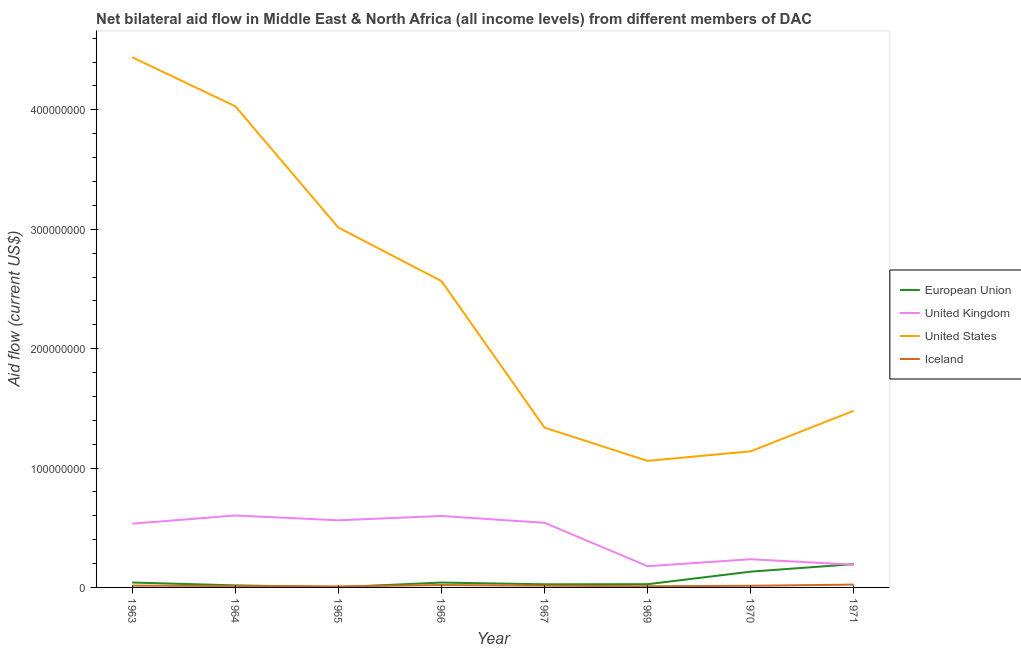How many different coloured lines are there?
Ensure brevity in your answer.  4. Is the number of lines equal to the number of legend labels?
Your answer should be very brief. Yes. What is the amount of aid given by eu in 1970?
Keep it short and to the point. 1.32e+07. Across all years, what is the maximum amount of aid given by uk?
Provide a short and direct response. 6.02e+07. Across all years, what is the minimum amount of aid given by us?
Provide a short and direct response. 1.06e+08. In which year was the amount of aid given by eu minimum?
Your answer should be very brief. 1965. What is the total amount of aid given by eu in the graph?
Provide a succinct answer. 4.82e+07. What is the difference between the amount of aid given by eu in 1963 and that in 1964?
Offer a very short reply. 2.40e+06. What is the difference between the amount of aid given by eu in 1969 and the amount of aid given by iceland in 1971?
Provide a short and direct response. 3.50e+05. What is the average amount of aid given by iceland per year?
Offer a very short reply. 1.46e+06. In the year 1967, what is the difference between the amount of aid given by eu and amount of aid given by us?
Your response must be concise. -1.31e+08. In how many years, is the amount of aid given by us greater than 300000000 US$?
Provide a succinct answer. 3. What is the ratio of the amount of aid given by us in 1966 to that in 1969?
Offer a very short reply. 2.42. Is the amount of aid given by uk in 1963 less than that in 1969?
Provide a succinct answer. No. What is the difference between the highest and the second highest amount of aid given by iceland?
Make the answer very short. 3.50e+05. What is the difference between the highest and the lowest amount of aid given by eu?
Give a very brief answer. 1.93e+07. In how many years, is the amount of aid given by uk greater than the average amount of aid given by uk taken over all years?
Make the answer very short. 5. Is it the case that in every year, the sum of the amount of aid given by eu and amount of aid given by uk is greater than the amount of aid given by us?
Provide a short and direct response. No. Does the amount of aid given by iceland monotonically increase over the years?
Your response must be concise. No. How many lines are there?
Your answer should be very brief. 4. What is the difference between two consecutive major ticks on the Y-axis?
Provide a succinct answer. 1.00e+08. Does the graph contain any zero values?
Ensure brevity in your answer.  No. Does the graph contain grids?
Give a very brief answer. No. Where does the legend appear in the graph?
Offer a very short reply. Center right. What is the title of the graph?
Ensure brevity in your answer.  Net bilateral aid flow in Middle East & North Africa (all income levels) from different members of DAC. What is the Aid flow (current US$) in European Union in 1963?
Give a very brief answer. 4.11e+06. What is the Aid flow (current US$) of United Kingdom in 1963?
Keep it short and to the point. 5.34e+07. What is the Aid flow (current US$) of United States in 1963?
Keep it short and to the point. 4.44e+08. What is the Aid flow (current US$) of Iceland in 1963?
Provide a short and direct response. 1.54e+06. What is the Aid flow (current US$) of European Union in 1964?
Your response must be concise. 1.71e+06. What is the Aid flow (current US$) in United Kingdom in 1964?
Your answer should be compact. 6.02e+07. What is the Aid flow (current US$) in United States in 1964?
Offer a terse response. 4.03e+08. What is the Aid flow (current US$) in Iceland in 1964?
Your response must be concise. 1.10e+06. What is the Aid flow (current US$) in United Kingdom in 1965?
Your answer should be very brief. 5.62e+07. What is the Aid flow (current US$) of United States in 1965?
Your answer should be very brief. 3.01e+08. What is the Aid flow (current US$) in Iceland in 1965?
Offer a very short reply. 8.70e+05. What is the Aid flow (current US$) of European Union in 1966?
Your answer should be very brief. 4.08e+06. What is the Aid flow (current US$) in United Kingdom in 1966?
Offer a very short reply. 5.98e+07. What is the Aid flow (current US$) of United States in 1966?
Provide a succinct answer. 2.57e+08. What is the Aid flow (current US$) in Iceland in 1966?
Provide a succinct answer. 2.01e+06. What is the Aid flow (current US$) in European Union in 1967?
Ensure brevity in your answer.  2.62e+06. What is the Aid flow (current US$) in United Kingdom in 1967?
Provide a succinct answer. 5.41e+07. What is the Aid flow (current US$) in United States in 1967?
Your answer should be very brief. 1.34e+08. What is the Aid flow (current US$) of Iceland in 1967?
Ensure brevity in your answer.  1.44e+06. What is the Aid flow (current US$) in European Union in 1969?
Your answer should be very brief. 2.71e+06. What is the Aid flow (current US$) of United Kingdom in 1969?
Ensure brevity in your answer.  1.78e+07. What is the Aid flow (current US$) of United States in 1969?
Ensure brevity in your answer.  1.06e+08. What is the Aid flow (current US$) in Iceland in 1969?
Your answer should be compact. 9.70e+05. What is the Aid flow (current US$) of European Union in 1970?
Provide a short and direct response. 1.32e+07. What is the Aid flow (current US$) of United Kingdom in 1970?
Keep it short and to the point. 2.36e+07. What is the Aid flow (current US$) in United States in 1970?
Ensure brevity in your answer.  1.14e+08. What is the Aid flow (current US$) of Iceland in 1970?
Provide a short and direct response. 1.37e+06. What is the Aid flow (current US$) of European Union in 1971?
Provide a short and direct response. 1.95e+07. What is the Aid flow (current US$) of United Kingdom in 1971?
Your response must be concise. 1.90e+07. What is the Aid flow (current US$) in United States in 1971?
Your answer should be compact. 1.48e+08. What is the Aid flow (current US$) of Iceland in 1971?
Keep it short and to the point. 2.36e+06. Across all years, what is the maximum Aid flow (current US$) of European Union?
Your answer should be compact. 1.95e+07. Across all years, what is the maximum Aid flow (current US$) in United Kingdom?
Offer a very short reply. 6.02e+07. Across all years, what is the maximum Aid flow (current US$) of United States?
Your response must be concise. 4.44e+08. Across all years, what is the maximum Aid flow (current US$) in Iceland?
Provide a succinct answer. 2.36e+06. Across all years, what is the minimum Aid flow (current US$) of European Union?
Offer a very short reply. 2.20e+05. Across all years, what is the minimum Aid flow (current US$) of United Kingdom?
Your answer should be very brief. 1.78e+07. Across all years, what is the minimum Aid flow (current US$) in United States?
Give a very brief answer. 1.06e+08. Across all years, what is the minimum Aid flow (current US$) of Iceland?
Offer a very short reply. 8.70e+05. What is the total Aid flow (current US$) of European Union in the graph?
Provide a succinct answer. 4.82e+07. What is the total Aid flow (current US$) in United Kingdom in the graph?
Offer a terse response. 3.44e+08. What is the total Aid flow (current US$) of United States in the graph?
Provide a short and direct response. 1.91e+09. What is the total Aid flow (current US$) of Iceland in the graph?
Offer a very short reply. 1.17e+07. What is the difference between the Aid flow (current US$) in European Union in 1963 and that in 1964?
Ensure brevity in your answer.  2.40e+06. What is the difference between the Aid flow (current US$) of United Kingdom in 1963 and that in 1964?
Your answer should be compact. -6.86e+06. What is the difference between the Aid flow (current US$) of United States in 1963 and that in 1964?
Provide a short and direct response. 4.10e+07. What is the difference between the Aid flow (current US$) of European Union in 1963 and that in 1965?
Make the answer very short. 3.89e+06. What is the difference between the Aid flow (current US$) of United Kingdom in 1963 and that in 1965?
Provide a succinct answer. -2.85e+06. What is the difference between the Aid flow (current US$) in United States in 1963 and that in 1965?
Your response must be concise. 1.43e+08. What is the difference between the Aid flow (current US$) of Iceland in 1963 and that in 1965?
Your response must be concise. 6.70e+05. What is the difference between the Aid flow (current US$) in European Union in 1963 and that in 1966?
Provide a succinct answer. 3.00e+04. What is the difference between the Aid flow (current US$) in United Kingdom in 1963 and that in 1966?
Give a very brief answer. -6.46e+06. What is the difference between the Aid flow (current US$) of United States in 1963 and that in 1966?
Your response must be concise. 1.87e+08. What is the difference between the Aid flow (current US$) in Iceland in 1963 and that in 1966?
Provide a succinct answer. -4.70e+05. What is the difference between the Aid flow (current US$) in European Union in 1963 and that in 1967?
Give a very brief answer. 1.49e+06. What is the difference between the Aid flow (current US$) of United Kingdom in 1963 and that in 1967?
Keep it short and to the point. -7.60e+05. What is the difference between the Aid flow (current US$) in United States in 1963 and that in 1967?
Give a very brief answer. 3.10e+08. What is the difference between the Aid flow (current US$) of European Union in 1963 and that in 1969?
Give a very brief answer. 1.40e+06. What is the difference between the Aid flow (current US$) in United Kingdom in 1963 and that in 1969?
Your response must be concise. 3.56e+07. What is the difference between the Aid flow (current US$) in United States in 1963 and that in 1969?
Offer a very short reply. 3.38e+08. What is the difference between the Aid flow (current US$) in Iceland in 1963 and that in 1969?
Offer a very short reply. 5.70e+05. What is the difference between the Aid flow (current US$) in European Union in 1963 and that in 1970?
Keep it short and to the point. -9.11e+06. What is the difference between the Aid flow (current US$) in United Kingdom in 1963 and that in 1970?
Provide a succinct answer. 2.98e+07. What is the difference between the Aid flow (current US$) of United States in 1963 and that in 1970?
Offer a terse response. 3.30e+08. What is the difference between the Aid flow (current US$) of European Union in 1963 and that in 1971?
Give a very brief answer. -1.54e+07. What is the difference between the Aid flow (current US$) of United Kingdom in 1963 and that in 1971?
Your answer should be compact. 3.43e+07. What is the difference between the Aid flow (current US$) in United States in 1963 and that in 1971?
Offer a very short reply. 2.96e+08. What is the difference between the Aid flow (current US$) in Iceland in 1963 and that in 1971?
Your answer should be compact. -8.20e+05. What is the difference between the Aid flow (current US$) of European Union in 1964 and that in 1965?
Your answer should be compact. 1.49e+06. What is the difference between the Aid flow (current US$) in United Kingdom in 1964 and that in 1965?
Offer a terse response. 4.01e+06. What is the difference between the Aid flow (current US$) of United States in 1964 and that in 1965?
Your response must be concise. 1.02e+08. What is the difference between the Aid flow (current US$) of Iceland in 1964 and that in 1965?
Give a very brief answer. 2.30e+05. What is the difference between the Aid flow (current US$) of European Union in 1964 and that in 1966?
Your answer should be compact. -2.37e+06. What is the difference between the Aid flow (current US$) in United Kingdom in 1964 and that in 1966?
Your answer should be compact. 4.00e+05. What is the difference between the Aid flow (current US$) of United States in 1964 and that in 1966?
Ensure brevity in your answer.  1.46e+08. What is the difference between the Aid flow (current US$) of Iceland in 1964 and that in 1966?
Your answer should be very brief. -9.10e+05. What is the difference between the Aid flow (current US$) in European Union in 1964 and that in 1967?
Provide a short and direct response. -9.10e+05. What is the difference between the Aid flow (current US$) in United Kingdom in 1964 and that in 1967?
Make the answer very short. 6.10e+06. What is the difference between the Aid flow (current US$) in United States in 1964 and that in 1967?
Make the answer very short. 2.69e+08. What is the difference between the Aid flow (current US$) in Iceland in 1964 and that in 1967?
Give a very brief answer. -3.40e+05. What is the difference between the Aid flow (current US$) in European Union in 1964 and that in 1969?
Provide a short and direct response. -1.00e+06. What is the difference between the Aid flow (current US$) in United Kingdom in 1964 and that in 1969?
Make the answer very short. 4.25e+07. What is the difference between the Aid flow (current US$) of United States in 1964 and that in 1969?
Your response must be concise. 2.97e+08. What is the difference between the Aid flow (current US$) of Iceland in 1964 and that in 1969?
Make the answer very short. 1.30e+05. What is the difference between the Aid flow (current US$) of European Union in 1964 and that in 1970?
Your answer should be compact. -1.15e+07. What is the difference between the Aid flow (current US$) of United Kingdom in 1964 and that in 1970?
Provide a succinct answer. 3.66e+07. What is the difference between the Aid flow (current US$) of United States in 1964 and that in 1970?
Provide a short and direct response. 2.89e+08. What is the difference between the Aid flow (current US$) of Iceland in 1964 and that in 1970?
Your answer should be compact. -2.70e+05. What is the difference between the Aid flow (current US$) of European Union in 1964 and that in 1971?
Ensure brevity in your answer.  -1.78e+07. What is the difference between the Aid flow (current US$) in United Kingdom in 1964 and that in 1971?
Your answer should be compact. 4.12e+07. What is the difference between the Aid flow (current US$) of United States in 1964 and that in 1971?
Keep it short and to the point. 2.55e+08. What is the difference between the Aid flow (current US$) of Iceland in 1964 and that in 1971?
Give a very brief answer. -1.26e+06. What is the difference between the Aid flow (current US$) of European Union in 1965 and that in 1966?
Your answer should be very brief. -3.86e+06. What is the difference between the Aid flow (current US$) of United Kingdom in 1965 and that in 1966?
Your answer should be compact. -3.61e+06. What is the difference between the Aid flow (current US$) in United States in 1965 and that in 1966?
Ensure brevity in your answer.  4.48e+07. What is the difference between the Aid flow (current US$) of Iceland in 1965 and that in 1966?
Ensure brevity in your answer.  -1.14e+06. What is the difference between the Aid flow (current US$) in European Union in 1965 and that in 1967?
Your answer should be compact. -2.40e+06. What is the difference between the Aid flow (current US$) in United Kingdom in 1965 and that in 1967?
Your response must be concise. 2.09e+06. What is the difference between the Aid flow (current US$) of United States in 1965 and that in 1967?
Your answer should be compact. 1.68e+08. What is the difference between the Aid flow (current US$) in Iceland in 1965 and that in 1967?
Give a very brief answer. -5.70e+05. What is the difference between the Aid flow (current US$) in European Union in 1965 and that in 1969?
Ensure brevity in your answer.  -2.49e+06. What is the difference between the Aid flow (current US$) of United Kingdom in 1965 and that in 1969?
Keep it short and to the point. 3.84e+07. What is the difference between the Aid flow (current US$) in United States in 1965 and that in 1969?
Offer a terse response. 1.95e+08. What is the difference between the Aid flow (current US$) in European Union in 1965 and that in 1970?
Provide a short and direct response. -1.30e+07. What is the difference between the Aid flow (current US$) in United Kingdom in 1965 and that in 1970?
Keep it short and to the point. 3.26e+07. What is the difference between the Aid flow (current US$) of United States in 1965 and that in 1970?
Your response must be concise. 1.87e+08. What is the difference between the Aid flow (current US$) in Iceland in 1965 and that in 1970?
Make the answer very short. -5.00e+05. What is the difference between the Aid flow (current US$) in European Union in 1965 and that in 1971?
Provide a short and direct response. -1.93e+07. What is the difference between the Aid flow (current US$) in United Kingdom in 1965 and that in 1971?
Offer a very short reply. 3.72e+07. What is the difference between the Aid flow (current US$) of United States in 1965 and that in 1971?
Provide a short and direct response. 1.53e+08. What is the difference between the Aid flow (current US$) in Iceland in 1965 and that in 1971?
Your answer should be compact. -1.49e+06. What is the difference between the Aid flow (current US$) of European Union in 1966 and that in 1967?
Give a very brief answer. 1.46e+06. What is the difference between the Aid flow (current US$) of United Kingdom in 1966 and that in 1967?
Your answer should be compact. 5.70e+06. What is the difference between the Aid flow (current US$) in United States in 1966 and that in 1967?
Offer a very short reply. 1.23e+08. What is the difference between the Aid flow (current US$) of Iceland in 1966 and that in 1967?
Make the answer very short. 5.70e+05. What is the difference between the Aid flow (current US$) of European Union in 1966 and that in 1969?
Give a very brief answer. 1.37e+06. What is the difference between the Aid flow (current US$) of United Kingdom in 1966 and that in 1969?
Provide a succinct answer. 4.21e+07. What is the difference between the Aid flow (current US$) of United States in 1966 and that in 1969?
Keep it short and to the point. 1.51e+08. What is the difference between the Aid flow (current US$) of Iceland in 1966 and that in 1969?
Your answer should be very brief. 1.04e+06. What is the difference between the Aid flow (current US$) in European Union in 1966 and that in 1970?
Offer a very short reply. -9.14e+06. What is the difference between the Aid flow (current US$) of United Kingdom in 1966 and that in 1970?
Your answer should be very brief. 3.62e+07. What is the difference between the Aid flow (current US$) of United States in 1966 and that in 1970?
Give a very brief answer. 1.43e+08. What is the difference between the Aid flow (current US$) in Iceland in 1966 and that in 1970?
Make the answer very short. 6.40e+05. What is the difference between the Aid flow (current US$) of European Union in 1966 and that in 1971?
Offer a very short reply. -1.54e+07. What is the difference between the Aid flow (current US$) in United Kingdom in 1966 and that in 1971?
Give a very brief answer. 4.08e+07. What is the difference between the Aid flow (current US$) of United States in 1966 and that in 1971?
Your answer should be compact. 1.09e+08. What is the difference between the Aid flow (current US$) of Iceland in 1966 and that in 1971?
Provide a succinct answer. -3.50e+05. What is the difference between the Aid flow (current US$) of United Kingdom in 1967 and that in 1969?
Provide a short and direct response. 3.64e+07. What is the difference between the Aid flow (current US$) of United States in 1967 and that in 1969?
Give a very brief answer. 2.78e+07. What is the difference between the Aid flow (current US$) in Iceland in 1967 and that in 1969?
Give a very brief answer. 4.70e+05. What is the difference between the Aid flow (current US$) in European Union in 1967 and that in 1970?
Offer a terse response. -1.06e+07. What is the difference between the Aid flow (current US$) in United Kingdom in 1967 and that in 1970?
Offer a very short reply. 3.05e+07. What is the difference between the Aid flow (current US$) of United States in 1967 and that in 1970?
Offer a terse response. 1.98e+07. What is the difference between the Aid flow (current US$) of European Union in 1967 and that in 1971?
Keep it short and to the point. -1.69e+07. What is the difference between the Aid flow (current US$) of United Kingdom in 1967 and that in 1971?
Offer a terse response. 3.51e+07. What is the difference between the Aid flow (current US$) in United States in 1967 and that in 1971?
Make the answer very short. -1.42e+07. What is the difference between the Aid flow (current US$) of Iceland in 1967 and that in 1971?
Your response must be concise. -9.20e+05. What is the difference between the Aid flow (current US$) of European Union in 1969 and that in 1970?
Ensure brevity in your answer.  -1.05e+07. What is the difference between the Aid flow (current US$) in United Kingdom in 1969 and that in 1970?
Provide a short and direct response. -5.83e+06. What is the difference between the Aid flow (current US$) of United States in 1969 and that in 1970?
Your answer should be compact. -8.00e+06. What is the difference between the Aid flow (current US$) of Iceland in 1969 and that in 1970?
Keep it short and to the point. -4.00e+05. What is the difference between the Aid flow (current US$) in European Union in 1969 and that in 1971?
Keep it short and to the point. -1.68e+07. What is the difference between the Aid flow (current US$) of United Kingdom in 1969 and that in 1971?
Your response must be concise. -1.26e+06. What is the difference between the Aid flow (current US$) in United States in 1969 and that in 1971?
Give a very brief answer. -4.20e+07. What is the difference between the Aid flow (current US$) in Iceland in 1969 and that in 1971?
Keep it short and to the point. -1.39e+06. What is the difference between the Aid flow (current US$) in European Union in 1970 and that in 1971?
Offer a very short reply. -6.29e+06. What is the difference between the Aid flow (current US$) of United Kingdom in 1970 and that in 1971?
Make the answer very short. 4.57e+06. What is the difference between the Aid flow (current US$) of United States in 1970 and that in 1971?
Your answer should be very brief. -3.40e+07. What is the difference between the Aid flow (current US$) in Iceland in 1970 and that in 1971?
Make the answer very short. -9.90e+05. What is the difference between the Aid flow (current US$) in European Union in 1963 and the Aid flow (current US$) in United Kingdom in 1964?
Provide a short and direct response. -5.61e+07. What is the difference between the Aid flow (current US$) in European Union in 1963 and the Aid flow (current US$) in United States in 1964?
Your response must be concise. -3.99e+08. What is the difference between the Aid flow (current US$) in European Union in 1963 and the Aid flow (current US$) in Iceland in 1964?
Provide a short and direct response. 3.01e+06. What is the difference between the Aid flow (current US$) of United Kingdom in 1963 and the Aid flow (current US$) of United States in 1964?
Make the answer very short. -3.50e+08. What is the difference between the Aid flow (current US$) in United Kingdom in 1963 and the Aid flow (current US$) in Iceland in 1964?
Ensure brevity in your answer.  5.23e+07. What is the difference between the Aid flow (current US$) in United States in 1963 and the Aid flow (current US$) in Iceland in 1964?
Provide a succinct answer. 4.43e+08. What is the difference between the Aid flow (current US$) in European Union in 1963 and the Aid flow (current US$) in United Kingdom in 1965?
Offer a very short reply. -5.21e+07. What is the difference between the Aid flow (current US$) in European Union in 1963 and the Aid flow (current US$) in United States in 1965?
Offer a very short reply. -2.97e+08. What is the difference between the Aid flow (current US$) of European Union in 1963 and the Aid flow (current US$) of Iceland in 1965?
Ensure brevity in your answer.  3.24e+06. What is the difference between the Aid flow (current US$) in United Kingdom in 1963 and the Aid flow (current US$) in United States in 1965?
Give a very brief answer. -2.48e+08. What is the difference between the Aid flow (current US$) of United Kingdom in 1963 and the Aid flow (current US$) of Iceland in 1965?
Provide a succinct answer. 5.25e+07. What is the difference between the Aid flow (current US$) in United States in 1963 and the Aid flow (current US$) in Iceland in 1965?
Your answer should be very brief. 4.43e+08. What is the difference between the Aid flow (current US$) of European Union in 1963 and the Aid flow (current US$) of United Kingdom in 1966?
Give a very brief answer. -5.57e+07. What is the difference between the Aid flow (current US$) in European Union in 1963 and the Aid flow (current US$) in United States in 1966?
Your answer should be very brief. -2.52e+08. What is the difference between the Aid flow (current US$) of European Union in 1963 and the Aid flow (current US$) of Iceland in 1966?
Your answer should be compact. 2.10e+06. What is the difference between the Aid flow (current US$) of United Kingdom in 1963 and the Aid flow (current US$) of United States in 1966?
Make the answer very short. -2.03e+08. What is the difference between the Aid flow (current US$) of United Kingdom in 1963 and the Aid flow (current US$) of Iceland in 1966?
Your response must be concise. 5.14e+07. What is the difference between the Aid flow (current US$) of United States in 1963 and the Aid flow (current US$) of Iceland in 1966?
Offer a terse response. 4.42e+08. What is the difference between the Aid flow (current US$) of European Union in 1963 and the Aid flow (current US$) of United Kingdom in 1967?
Your answer should be compact. -5.00e+07. What is the difference between the Aid flow (current US$) of European Union in 1963 and the Aid flow (current US$) of United States in 1967?
Make the answer very short. -1.30e+08. What is the difference between the Aid flow (current US$) in European Union in 1963 and the Aid flow (current US$) in Iceland in 1967?
Provide a short and direct response. 2.67e+06. What is the difference between the Aid flow (current US$) in United Kingdom in 1963 and the Aid flow (current US$) in United States in 1967?
Make the answer very short. -8.04e+07. What is the difference between the Aid flow (current US$) of United Kingdom in 1963 and the Aid flow (current US$) of Iceland in 1967?
Offer a terse response. 5.19e+07. What is the difference between the Aid flow (current US$) of United States in 1963 and the Aid flow (current US$) of Iceland in 1967?
Offer a terse response. 4.43e+08. What is the difference between the Aid flow (current US$) of European Union in 1963 and the Aid flow (current US$) of United Kingdom in 1969?
Give a very brief answer. -1.37e+07. What is the difference between the Aid flow (current US$) of European Union in 1963 and the Aid flow (current US$) of United States in 1969?
Offer a terse response. -1.02e+08. What is the difference between the Aid flow (current US$) in European Union in 1963 and the Aid flow (current US$) in Iceland in 1969?
Provide a succinct answer. 3.14e+06. What is the difference between the Aid flow (current US$) in United Kingdom in 1963 and the Aid flow (current US$) in United States in 1969?
Keep it short and to the point. -5.26e+07. What is the difference between the Aid flow (current US$) of United Kingdom in 1963 and the Aid flow (current US$) of Iceland in 1969?
Offer a very short reply. 5.24e+07. What is the difference between the Aid flow (current US$) in United States in 1963 and the Aid flow (current US$) in Iceland in 1969?
Your answer should be very brief. 4.43e+08. What is the difference between the Aid flow (current US$) in European Union in 1963 and the Aid flow (current US$) in United Kingdom in 1970?
Provide a succinct answer. -1.95e+07. What is the difference between the Aid flow (current US$) of European Union in 1963 and the Aid flow (current US$) of United States in 1970?
Offer a terse response. -1.10e+08. What is the difference between the Aid flow (current US$) in European Union in 1963 and the Aid flow (current US$) in Iceland in 1970?
Your answer should be compact. 2.74e+06. What is the difference between the Aid flow (current US$) of United Kingdom in 1963 and the Aid flow (current US$) of United States in 1970?
Give a very brief answer. -6.06e+07. What is the difference between the Aid flow (current US$) in United Kingdom in 1963 and the Aid flow (current US$) in Iceland in 1970?
Your answer should be compact. 5.20e+07. What is the difference between the Aid flow (current US$) in United States in 1963 and the Aid flow (current US$) in Iceland in 1970?
Offer a very short reply. 4.43e+08. What is the difference between the Aid flow (current US$) in European Union in 1963 and the Aid flow (current US$) in United Kingdom in 1971?
Ensure brevity in your answer.  -1.49e+07. What is the difference between the Aid flow (current US$) in European Union in 1963 and the Aid flow (current US$) in United States in 1971?
Provide a short and direct response. -1.44e+08. What is the difference between the Aid flow (current US$) in European Union in 1963 and the Aid flow (current US$) in Iceland in 1971?
Give a very brief answer. 1.75e+06. What is the difference between the Aid flow (current US$) of United Kingdom in 1963 and the Aid flow (current US$) of United States in 1971?
Offer a very short reply. -9.46e+07. What is the difference between the Aid flow (current US$) of United Kingdom in 1963 and the Aid flow (current US$) of Iceland in 1971?
Your answer should be very brief. 5.10e+07. What is the difference between the Aid flow (current US$) in United States in 1963 and the Aid flow (current US$) in Iceland in 1971?
Make the answer very short. 4.42e+08. What is the difference between the Aid flow (current US$) in European Union in 1964 and the Aid flow (current US$) in United Kingdom in 1965?
Ensure brevity in your answer.  -5.45e+07. What is the difference between the Aid flow (current US$) of European Union in 1964 and the Aid flow (current US$) of United States in 1965?
Your answer should be compact. -3.00e+08. What is the difference between the Aid flow (current US$) in European Union in 1964 and the Aid flow (current US$) in Iceland in 1965?
Give a very brief answer. 8.40e+05. What is the difference between the Aid flow (current US$) in United Kingdom in 1964 and the Aid flow (current US$) in United States in 1965?
Make the answer very short. -2.41e+08. What is the difference between the Aid flow (current US$) of United Kingdom in 1964 and the Aid flow (current US$) of Iceland in 1965?
Offer a terse response. 5.94e+07. What is the difference between the Aid flow (current US$) of United States in 1964 and the Aid flow (current US$) of Iceland in 1965?
Keep it short and to the point. 4.02e+08. What is the difference between the Aid flow (current US$) of European Union in 1964 and the Aid flow (current US$) of United Kingdom in 1966?
Offer a terse response. -5.81e+07. What is the difference between the Aid flow (current US$) in European Union in 1964 and the Aid flow (current US$) in United States in 1966?
Give a very brief answer. -2.55e+08. What is the difference between the Aid flow (current US$) in United Kingdom in 1964 and the Aid flow (current US$) in United States in 1966?
Your answer should be compact. -1.96e+08. What is the difference between the Aid flow (current US$) of United Kingdom in 1964 and the Aid flow (current US$) of Iceland in 1966?
Offer a very short reply. 5.82e+07. What is the difference between the Aid flow (current US$) in United States in 1964 and the Aid flow (current US$) in Iceland in 1966?
Keep it short and to the point. 4.01e+08. What is the difference between the Aid flow (current US$) in European Union in 1964 and the Aid flow (current US$) in United Kingdom in 1967?
Provide a short and direct response. -5.24e+07. What is the difference between the Aid flow (current US$) in European Union in 1964 and the Aid flow (current US$) in United States in 1967?
Your answer should be very brief. -1.32e+08. What is the difference between the Aid flow (current US$) of European Union in 1964 and the Aid flow (current US$) of Iceland in 1967?
Offer a very short reply. 2.70e+05. What is the difference between the Aid flow (current US$) in United Kingdom in 1964 and the Aid flow (current US$) in United States in 1967?
Keep it short and to the point. -7.36e+07. What is the difference between the Aid flow (current US$) of United Kingdom in 1964 and the Aid flow (current US$) of Iceland in 1967?
Offer a very short reply. 5.88e+07. What is the difference between the Aid flow (current US$) of United States in 1964 and the Aid flow (current US$) of Iceland in 1967?
Your answer should be compact. 4.02e+08. What is the difference between the Aid flow (current US$) of European Union in 1964 and the Aid flow (current US$) of United Kingdom in 1969?
Offer a very short reply. -1.61e+07. What is the difference between the Aid flow (current US$) of European Union in 1964 and the Aid flow (current US$) of United States in 1969?
Offer a terse response. -1.04e+08. What is the difference between the Aid flow (current US$) in European Union in 1964 and the Aid flow (current US$) in Iceland in 1969?
Provide a succinct answer. 7.40e+05. What is the difference between the Aid flow (current US$) of United Kingdom in 1964 and the Aid flow (current US$) of United States in 1969?
Provide a succinct answer. -4.58e+07. What is the difference between the Aid flow (current US$) of United Kingdom in 1964 and the Aid flow (current US$) of Iceland in 1969?
Provide a succinct answer. 5.93e+07. What is the difference between the Aid flow (current US$) of United States in 1964 and the Aid flow (current US$) of Iceland in 1969?
Provide a short and direct response. 4.02e+08. What is the difference between the Aid flow (current US$) of European Union in 1964 and the Aid flow (current US$) of United Kingdom in 1970?
Give a very brief answer. -2.19e+07. What is the difference between the Aid flow (current US$) of European Union in 1964 and the Aid flow (current US$) of United States in 1970?
Offer a terse response. -1.12e+08. What is the difference between the Aid flow (current US$) in United Kingdom in 1964 and the Aid flow (current US$) in United States in 1970?
Keep it short and to the point. -5.38e+07. What is the difference between the Aid flow (current US$) in United Kingdom in 1964 and the Aid flow (current US$) in Iceland in 1970?
Offer a terse response. 5.89e+07. What is the difference between the Aid flow (current US$) of United States in 1964 and the Aid flow (current US$) of Iceland in 1970?
Your answer should be very brief. 4.02e+08. What is the difference between the Aid flow (current US$) in European Union in 1964 and the Aid flow (current US$) in United Kingdom in 1971?
Offer a terse response. -1.73e+07. What is the difference between the Aid flow (current US$) of European Union in 1964 and the Aid flow (current US$) of United States in 1971?
Ensure brevity in your answer.  -1.46e+08. What is the difference between the Aid flow (current US$) in European Union in 1964 and the Aid flow (current US$) in Iceland in 1971?
Your answer should be compact. -6.50e+05. What is the difference between the Aid flow (current US$) in United Kingdom in 1964 and the Aid flow (current US$) in United States in 1971?
Provide a short and direct response. -8.78e+07. What is the difference between the Aid flow (current US$) of United Kingdom in 1964 and the Aid flow (current US$) of Iceland in 1971?
Make the answer very short. 5.79e+07. What is the difference between the Aid flow (current US$) of United States in 1964 and the Aid flow (current US$) of Iceland in 1971?
Your response must be concise. 4.01e+08. What is the difference between the Aid flow (current US$) of European Union in 1965 and the Aid flow (current US$) of United Kingdom in 1966?
Keep it short and to the point. -5.96e+07. What is the difference between the Aid flow (current US$) of European Union in 1965 and the Aid flow (current US$) of United States in 1966?
Offer a terse response. -2.56e+08. What is the difference between the Aid flow (current US$) in European Union in 1965 and the Aid flow (current US$) in Iceland in 1966?
Ensure brevity in your answer.  -1.79e+06. What is the difference between the Aid flow (current US$) in United Kingdom in 1965 and the Aid flow (current US$) in United States in 1966?
Offer a very short reply. -2.00e+08. What is the difference between the Aid flow (current US$) of United Kingdom in 1965 and the Aid flow (current US$) of Iceland in 1966?
Make the answer very short. 5.42e+07. What is the difference between the Aid flow (current US$) of United States in 1965 and the Aid flow (current US$) of Iceland in 1966?
Offer a very short reply. 2.99e+08. What is the difference between the Aid flow (current US$) in European Union in 1965 and the Aid flow (current US$) in United Kingdom in 1967?
Your answer should be very brief. -5.39e+07. What is the difference between the Aid flow (current US$) in European Union in 1965 and the Aid flow (current US$) in United States in 1967?
Ensure brevity in your answer.  -1.34e+08. What is the difference between the Aid flow (current US$) of European Union in 1965 and the Aid flow (current US$) of Iceland in 1967?
Your answer should be compact. -1.22e+06. What is the difference between the Aid flow (current US$) in United Kingdom in 1965 and the Aid flow (current US$) in United States in 1967?
Your response must be concise. -7.76e+07. What is the difference between the Aid flow (current US$) of United Kingdom in 1965 and the Aid flow (current US$) of Iceland in 1967?
Provide a short and direct response. 5.48e+07. What is the difference between the Aid flow (current US$) of United States in 1965 and the Aid flow (current US$) of Iceland in 1967?
Give a very brief answer. 3.00e+08. What is the difference between the Aid flow (current US$) in European Union in 1965 and the Aid flow (current US$) in United Kingdom in 1969?
Offer a very short reply. -1.76e+07. What is the difference between the Aid flow (current US$) of European Union in 1965 and the Aid flow (current US$) of United States in 1969?
Your response must be concise. -1.06e+08. What is the difference between the Aid flow (current US$) of European Union in 1965 and the Aid flow (current US$) of Iceland in 1969?
Your response must be concise. -7.50e+05. What is the difference between the Aid flow (current US$) in United Kingdom in 1965 and the Aid flow (current US$) in United States in 1969?
Provide a short and direct response. -4.98e+07. What is the difference between the Aid flow (current US$) in United Kingdom in 1965 and the Aid flow (current US$) in Iceland in 1969?
Provide a succinct answer. 5.53e+07. What is the difference between the Aid flow (current US$) of United States in 1965 and the Aid flow (current US$) of Iceland in 1969?
Your answer should be very brief. 3.00e+08. What is the difference between the Aid flow (current US$) of European Union in 1965 and the Aid flow (current US$) of United Kingdom in 1970?
Your response must be concise. -2.34e+07. What is the difference between the Aid flow (current US$) of European Union in 1965 and the Aid flow (current US$) of United States in 1970?
Your answer should be compact. -1.14e+08. What is the difference between the Aid flow (current US$) of European Union in 1965 and the Aid flow (current US$) of Iceland in 1970?
Make the answer very short. -1.15e+06. What is the difference between the Aid flow (current US$) in United Kingdom in 1965 and the Aid flow (current US$) in United States in 1970?
Your answer should be very brief. -5.78e+07. What is the difference between the Aid flow (current US$) in United Kingdom in 1965 and the Aid flow (current US$) in Iceland in 1970?
Make the answer very short. 5.49e+07. What is the difference between the Aid flow (current US$) of United States in 1965 and the Aid flow (current US$) of Iceland in 1970?
Provide a succinct answer. 3.00e+08. What is the difference between the Aid flow (current US$) in European Union in 1965 and the Aid flow (current US$) in United Kingdom in 1971?
Your response must be concise. -1.88e+07. What is the difference between the Aid flow (current US$) of European Union in 1965 and the Aid flow (current US$) of United States in 1971?
Your response must be concise. -1.48e+08. What is the difference between the Aid flow (current US$) of European Union in 1965 and the Aid flow (current US$) of Iceland in 1971?
Ensure brevity in your answer.  -2.14e+06. What is the difference between the Aid flow (current US$) of United Kingdom in 1965 and the Aid flow (current US$) of United States in 1971?
Your answer should be very brief. -9.18e+07. What is the difference between the Aid flow (current US$) of United Kingdom in 1965 and the Aid flow (current US$) of Iceland in 1971?
Your answer should be very brief. 5.39e+07. What is the difference between the Aid flow (current US$) of United States in 1965 and the Aid flow (current US$) of Iceland in 1971?
Provide a succinct answer. 2.99e+08. What is the difference between the Aid flow (current US$) of European Union in 1966 and the Aid flow (current US$) of United Kingdom in 1967?
Provide a short and direct response. -5.01e+07. What is the difference between the Aid flow (current US$) of European Union in 1966 and the Aid flow (current US$) of United States in 1967?
Your response must be concise. -1.30e+08. What is the difference between the Aid flow (current US$) in European Union in 1966 and the Aid flow (current US$) in Iceland in 1967?
Offer a very short reply. 2.64e+06. What is the difference between the Aid flow (current US$) in United Kingdom in 1966 and the Aid flow (current US$) in United States in 1967?
Keep it short and to the point. -7.40e+07. What is the difference between the Aid flow (current US$) in United Kingdom in 1966 and the Aid flow (current US$) in Iceland in 1967?
Ensure brevity in your answer.  5.84e+07. What is the difference between the Aid flow (current US$) in United States in 1966 and the Aid flow (current US$) in Iceland in 1967?
Your answer should be compact. 2.55e+08. What is the difference between the Aid flow (current US$) of European Union in 1966 and the Aid flow (current US$) of United Kingdom in 1969?
Make the answer very short. -1.37e+07. What is the difference between the Aid flow (current US$) in European Union in 1966 and the Aid flow (current US$) in United States in 1969?
Offer a very short reply. -1.02e+08. What is the difference between the Aid flow (current US$) of European Union in 1966 and the Aid flow (current US$) of Iceland in 1969?
Give a very brief answer. 3.11e+06. What is the difference between the Aid flow (current US$) in United Kingdom in 1966 and the Aid flow (current US$) in United States in 1969?
Offer a terse response. -4.62e+07. What is the difference between the Aid flow (current US$) of United Kingdom in 1966 and the Aid flow (current US$) of Iceland in 1969?
Your answer should be very brief. 5.89e+07. What is the difference between the Aid flow (current US$) in United States in 1966 and the Aid flow (current US$) in Iceland in 1969?
Give a very brief answer. 2.56e+08. What is the difference between the Aid flow (current US$) in European Union in 1966 and the Aid flow (current US$) in United Kingdom in 1970?
Offer a very short reply. -1.95e+07. What is the difference between the Aid flow (current US$) of European Union in 1966 and the Aid flow (current US$) of United States in 1970?
Ensure brevity in your answer.  -1.10e+08. What is the difference between the Aid flow (current US$) of European Union in 1966 and the Aid flow (current US$) of Iceland in 1970?
Ensure brevity in your answer.  2.71e+06. What is the difference between the Aid flow (current US$) in United Kingdom in 1966 and the Aid flow (current US$) in United States in 1970?
Your answer should be very brief. -5.42e+07. What is the difference between the Aid flow (current US$) of United Kingdom in 1966 and the Aid flow (current US$) of Iceland in 1970?
Provide a short and direct response. 5.85e+07. What is the difference between the Aid flow (current US$) in United States in 1966 and the Aid flow (current US$) in Iceland in 1970?
Provide a short and direct response. 2.55e+08. What is the difference between the Aid flow (current US$) of European Union in 1966 and the Aid flow (current US$) of United Kingdom in 1971?
Provide a succinct answer. -1.50e+07. What is the difference between the Aid flow (current US$) of European Union in 1966 and the Aid flow (current US$) of United States in 1971?
Offer a terse response. -1.44e+08. What is the difference between the Aid flow (current US$) in European Union in 1966 and the Aid flow (current US$) in Iceland in 1971?
Ensure brevity in your answer.  1.72e+06. What is the difference between the Aid flow (current US$) in United Kingdom in 1966 and the Aid flow (current US$) in United States in 1971?
Your response must be concise. -8.82e+07. What is the difference between the Aid flow (current US$) in United Kingdom in 1966 and the Aid flow (current US$) in Iceland in 1971?
Provide a succinct answer. 5.75e+07. What is the difference between the Aid flow (current US$) in United States in 1966 and the Aid flow (current US$) in Iceland in 1971?
Keep it short and to the point. 2.54e+08. What is the difference between the Aid flow (current US$) of European Union in 1967 and the Aid flow (current US$) of United Kingdom in 1969?
Ensure brevity in your answer.  -1.52e+07. What is the difference between the Aid flow (current US$) of European Union in 1967 and the Aid flow (current US$) of United States in 1969?
Give a very brief answer. -1.03e+08. What is the difference between the Aid flow (current US$) in European Union in 1967 and the Aid flow (current US$) in Iceland in 1969?
Your answer should be compact. 1.65e+06. What is the difference between the Aid flow (current US$) in United Kingdom in 1967 and the Aid flow (current US$) in United States in 1969?
Give a very brief answer. -5.19e+07. What is the difference between the Aid flow (current US$) in United Kingdom in 1967 and the Aid flow (current US$) in Iceland in 1969?
Offer a very short reply. 5.32e+07. What is the difference between the Aid flow (current US$) of United States in 1967 and the Aid flow (current US$) of Iceland in 1969?
Give a very brief answer. 1.33e+08. What is the difference between the Aid flow (current US$) in European Union in 1967 and the Aid flow (current US$) in United Kingdom in 1970?
Offer a terse response. -2.10e+07. What is the difference between the Aid flow (current US$) in European Union in 1967 and the Aid flow (current US$) in United States in 1970?
Make the answer very short. -1.11e+08. What is the difference between the Aid flow (current US$) of European Union in 1967 and the Aid flow (current US$) of Iceland in 1970?
Ensure brevity in your answer.  1.25e+06. What is the difference between the Aid flow (current US$) in United Kingdom in 1967 and the Aid flow (current US$) in United States in 1970?
Give a very brief answer. -5.99e+07. What is the difference between the Aid flow (current US$) of United Kingdom in 1967 and the Aid flow (current US$) of Iceland in 1970?
Your answer should be compact. 5.28e+07. What is the difference between the Aid flow (current US$) in United States in 1967 and the Aid flow (current US$) in Iceland in 1970?
Make the answer very short. 1.32e+08. What is the difference between the Aid flow (current US$) in European Union in 1967 and the Aid flow (current US$) in United Kingdom in 1971?
Give a very brief answer. -1.64e+07. What is the difference between the Aid flow (current US$) of European Union in 1967 and the Aid flow (current US$) of United States in 1971?
Offer a very short reply. -1.45e+08. What is the difference between the Aid flow (current US$) in United Kingdom in 1967 and the Aid flow (current US$) in United States in 1971?
Keep it short and to the point. -9.39e+07. What is the difference between the Aid flow (current US$) in United Kingdom in 1967 and the Aid flow (current US$) in Iceland in 1971?
Keep it short and to the point. 5.18e+07. What is the difference between the Aid flow (current US$) in United States in 1967 and the Aid flow (current US$) in Iceland in 1971?
Make the answer very short. 1.31e+08. What is the difference between the Aid flow (current US$) of European Union in 1969 and the Aid flow (current US$) of United Kingdom in 1970?
Provide a succinct answer. -2.09e+07. What is the difference between the Aid flow (current US$) in European Union in 1969 and the Aid flow (current US$) in United States in 1970?
Provide a succinct answer. -1.11e+08. What is the difference between the Aid flow (current US$) in European Union in 1969 and the Aid flow (current US$) in Iceland in 1970?
Give a very brief answer. 1.34e+06. What is the difference between the Aid flow (current US$) of United Kingdom in 1969 and the Aid flow (current US$) of United States in 1970?
Your answer should be compact. -9.62e+07. What is the difference between the Aid flow (current US$) of United Kingdom in 1969 and the Aid flow (current US$) of Iceland in 1970?
Your response must be concise. 1.64e+07. What is the difference between the Aid flow (current US$) in United States in 1969 and the Aid flow (current US$) in Iceland in 1970?
Your answer should be very brief. 1.05e+08. What is the difference between the Aid flow (current US$) in European Union in 1969 and the Aid flow (current US$) in United Kingdom in 1971?
Your response must be concise. -1.63e+07. What is the difference between the Aid flow (current US$) of European Union in 1969 and the Aid flow (current US$) of United States in 1971?
Your response must be concise. -1.45e+08. What is the difference between the Aid flow (current US$) of United Kingdom in 1969 and the Aid flow (current US$) of United States in 1971?
Give a very brief answer. -1.30e+08. What is the difference between the Aid flow (current US$) in United Kingdom in 1969 and the Aid flow (current US$) in Iceland in 1971?
Provide a short and direct response. 1.54e+07. What is the difference between the Aid flow (current US$) in United States in 1969 and the Aid flow (current US$) in Iceland in 1971?
Provide a succinct answer. 1.04e+08. What is the difference between the Aid flow (current US$) of European Union in 1970 and the Aid flow (current US$) of United Kingdom in 1971?
Provide a short and direct response. -5.82e+06. What is the difference between the Aid flow (current US$) of European Union in 1970 and the Aid flow (current US$) of United States in 1971?
Make the answer very short. -1.35e+08. What is the difference between the Aid flow (current US$) of European Union in 1970 and the Aid flow (current US$) of Iceland in 1971?
Offer a very short reply. 1.09e+07. What is the difference between the Aid flow (current US$) of United Kingdom in 1970 and the Aid flow (current US$) of United States in 1971?
Offer a terse response. -1.24e+08. What is the difference between the Aid flow (current US$) in United Kingdom in 1970 and the Aid flow (current US$) in Iceland in 1971?
Give a very brief answer. 2.12e+07. What is the difference between the Aid flow (current US$) of United States in 1970 and the Aid flow (current US$) of Iceland in 1971?
Offer a very short reply. 1.12e+08. What is the average Aid flow (current US$) of European Union per year?
Make the answer very short. 6.02e+06. What is the average Aid flow (current US$) of United Kingdom per year?
Your answer should be very brief. 4.30e+07. What is the average Aid flow (current US$) of United States per year?
Make the answer very short. 2.38e+08. What is the average Aid flow (current US$) in Iceland per year?
Ensure brevity in your answer.  1.46e+06. In the year 1963, what is the difference between the Aid flow (current US$) of European Union and Aid flow (current US$) of United Kingdom?
Your response must be concise. -4.93e+07. In the year 1963, what is the difference between the Aid flow (current US$) in European Union and Aid flow (current US$) in United States?
Your answer should be compact. -4.40e+08. In the year 1963, what is the difference between the Aid flow (current US$) in European Union and Aid flow (current US$) in Iceland?
Provide a short and direct response. 2.57e+06. In the year 1963, what is the difference between the Aid flow (current US$) in United Kingdom and Aid flow (current US$) in United States?
Offer a terse response. -3.91e+08. In the year 1963, what is the difference between the Aid flow (current US$) of United Kingdom and Aid flow (current US$) of Iceland?
Offer a very short reply. 5.18e+07. In the year 1963, what is the difference between the Aid flow (current US$) in United States and Aid flow (current US$) in Iceland?
Offer a very short reply. 4.42e+08. In the year 1964, what is the difference between the Aid flow (current US$) in European Union and Aid flow (current US$) in United Kingdom?
Provide a short and direct response. -5.85e+07. In the year 1964, what is the difference between the Aid flow (current US$) in European Union and Aid flow (current US$) in United States?
Offer a terse response. -4.01e+08. In the year 1964, what is the difference between the Aid flow (current US$) of European Union and Aid flow (current US$) of Iceland?
Provide a short and direct response. 6.10e+05. In the year 1964, what is the difference between the Aid flow (current US$) in United Kingdom and Aid flow (current US$) in United States?
Offer a very short reply. -3.43e+08. In the year 1964, what is the difference between the Aid flow (current US$) in United Kingdom and Aid flow (current US$) in Iceland?
Give a very brief answer. 5.91e+07. In the year 1964, what is the difference between the Aid flow (current US$) in United States and Aid flow (current US$) in Iceland?
Your answer should be compact. 4.02e+08. In the year 1965, what is the difference between the Aid flow (current US$) of European Union and Aid flow (current US$) of United Kingdom?
Provide a short and direct response. -5.60e+07. In the year 1965, what is the difference between the Aid flow (current US$) in European Union and Aid flow (current US$) in United States?
Your answer should be compact. -3.01e+08. In the year 1965, what is the difference between the Aid flow (current US$) in European Union and Aid flow (current US$) in Iceland?
Provide a short and direct response. -6.50e+05. In the year 1965, what is the difference between the Aid flow (current US$) of United Kingdom and Aid flow (current US$) of United States?
Give a very brief answer. -2.45e+08. In the year 1965, what is the difference between the Aid flow (current US$) of United Kingdom and Aid flow (current US$) of Iceland?
Give a very brief answer. 5.54e+07. In the year 1965, what is the difference between the Aid flow (current US$) of United States and Aid flow (current US$) of Iceland?
Your response must be concise. 3.00e+08. In the year 1966, what is the difference between the Aid flow (current US$) in European Union and Aid flow (current US$) in United Kingdom?
Provide a succinct answer. -5.58e+07. In the year 1966, what is the difference between the Aid flow (current US$) in European Union and Aid flow (current US$) in United States?
Your response must be concise. -2.53e+08. In the year 1966, what is the difference between the Aid flow (current US$) of European Union and Aid flow (current US$) of Iceland?
Make the answer very short. 2.07e+06. In the year 1966, what is the difference between the Aid flow (current US$) of United Kingdom and Aid flow (current US$) of United States?
Keep it short and to the point. -1.97e+08. In the year 1966, what is the difference between the Aid flow (current US$) of United Kingdom and Aid flow (current US$) of Iceland?
Your response must be concise. 5.78e+07. In the year 1966, what is the difference between the Aid flow (current US$) in United States and Aid flow (current US$) in Iceland?
Offer a very short reply. 2.55e+08. In the year 1967, what is the difference between the Aid flow (current US$) in European Union and Aid flow (current US$) in United Kingdom?
Keep it short and to the point. -5.15e+07. In the year 1967, what is the difference between the Aid flow (current US$) in European Union and Aid flow (current US$) in United States?
Provide a short and direct response. -1.31e+08. In the year 1967, what is the difference between the Aid flow (current US$) of European Union and Aid flow (current US$) of Iceland?
Provide a succinct answer. 1.18e+06. In the year 1967, what is the difference between the Aid flow (current US$) in United Kingdom and Aid flow (current US$) in United States?
Provide a succinct answer. -7.97e+07. In the year 1967, what is the difference between the Aid flow (current US$) of United Kingdom and Aid flow (current US$) of Iceland?
Offer a terse response. 5.27e+07. In the year 1967, what is the difference between the Aid flow (current US$) of United States and Aid flow (current US$) of Iceland?
Your response must be concise. 1.32e+08. In the year 1969, what is the difference between the Aid flow (current US$) in European Union and Aid flow (current US$) in United Kingdom?
Offer a terse response. -1.51e+07. In the year 1969, what is the difference between the Aid flow (current US$) in European Union and Aid flow (current US$) in United States?
Make the answer very short. -1.03e+08. In the year 1969, what is the difference between the Aid flow (current US$) of European Union and Aid flow (current US$) of Iceland?
Offer a terse response. 1.74e+06. In the year 1969, what is the difference between the Aid flow (current US$) of United Kingdom and Aid flow (current US$) of United States?
Provide a succinct answer. -8.82e+07. In the year 1969, what is the difference between the Aid flow (current US$) of United Kingdom and Aid flow (current US$) of Iceland?
Your answer should be compact. 1.68e+07. In the year 1969, what is the difference between the Aid flow (current US$) of United States and Aid flow (current US$) of Iceland?
Make the answer very short. 1.05e+08. In the year 1970, what is the difference between the Aid flow (current US$) in European Union and Aid flow (current US$) in United Kingdom?
Offer a very short reply. -1.04e+07. In the year 1970, what is the difference between the Aid flow (current US$) in European Union and Aid flow (current US$) in United States?
Ensure brevity in your answer.  -1.01e+08. In the year 1970, what is the difference between the Aid flow (current US$) of European Union and Aid flow (current US$) of Iceland?
Give a very brief answer. 1.18e+07. In the year 1970, what is the difference between the Aid flow (current US$) of United Kingdom and Aid flow (current US$) of United States?
Your answer should be compact. -9.04e+07. In the year 1970, what is the difference between the Aid flow (current US$) of United Kingdom and Aid flow (current US$) of Iceland?
Your answer should be very brief. 2.22e+07. In the year 1970, what is the difference between the Aid flow (current US$) of United States and Aid flow (current US$) of Iceland?
Your response must be concise. 1.13e+08. In the year 1971, what is the difference between the Aid flow (current US$) in European Union and Aid flow (current US$) in United States?
Give a very brief answer. -1.28e+08. In the year 1971, what is the difference between the Aid flow (current US$) in European Union and Aid flow (current US$) in Iceland?
Offer a terse response. 1.72e+07. In the year 1971, what is the difference between the Aid flow (current US$) of United Kingdom and Aid flow (current US$) of United States?
Ensure brevity in your answer.  -1.29e+08. In the year 1971, what is the difference between the Aid flow (current US$) of United Kingdom and Aid flow (current US$) of Iceland?
Offer a very short reply. 1.67e+07. In the year 1971, what is the difference between the Aid flow (current US$) in United States and Aid flow (current US$) in Iceland?
Ensure brevity in your answer.  1.46e+08. What is the ratio of the Aid flow (current US$) in European Union in 1963 to that in 1964?
Provide a succinct answer. 2.4. What is the ratio of the Aid flow (current US$) of United Kingdom in 1963 to that in 1964?
Give a very brief answer. 0.89. What is the ratio of the Aid flow (current US$) in United States in 1963 to that in 1964?
Ensure brevity in your answer.  1.1. What is the ratio of the Aid flow (current US$) of Iceland in 1963 to that in 1964?
Offer a terse response. 1.4. What is the ratio of the Aid flow (current US$) in European Union in 1963 to that in 1965?
Provide a succinct answer. 18.68. What is the ratio of the Aid flow (current US$) in United Kingdom in 1963 to that in 1965?
Give a very brief answer. 0.95. What is the ratio of the Aid flow (current US$) of United States in 1963 to that in 1965?
Keep it short and to the point. 1.47. What is the ratio of the Aid flow (current US$) of Iceland in 1963 to that in 1965?
Offer a very short reply. 1.77. What is the ratio of the Aid flow (current US$) in European Union in 1963 to that in 1966?
Your answer should be compact. 1.01. What is the ratio of the Aid flow (current US$) of United Kingdom in 1963 to that in 1966?
Offer a very short reply. 0.89. What is the ratio of the Aid flow (current US$) of United States in 1963 to that in 1966?
Ensure brevity in your answer.  1.73. What is the ratio of the Aid flow (current US$) of Iceland in 1963 to that in 1966?
Provide a succinct answer. 0.77. What is the ratio of the Aid flow (current US$) in European Union in 1963 to that in 1967?
Make the answer very short. 1.57. What is the ratio of the Aid flow (current US$) in United Kingdom in 1963 to that in 1967?
Offer a terse response. 0.99. What is the ratio of the Aid flow (current US$) in United States in 1963 to that in 1967?
Provide a short and direct response. 3.32. What is the ratio of the Aid flow (current US$) of Iceland in 1963 to that in 1967?
Keep it short and to the point. 1.07. What is the ratio of the Aid flow (current US$) in European Union in 1963 to that in 1969?
Your answer should be compact. 1.52. What is the ratio of the Aid flow (current US$) in United Kingdom in 1963 to that in 1969?
Your answer should be very brief. 3. What is the ratio of the Aid flow (current US$) of United States in 1963 to that in 1969?
Offer a terse response. 4.19. What is the ratio of the Aid flow (current US$) in Iceland in 1963 to that in 1969?
Give a very brief answer. 1.59. What is the ratio of the Aid flow (current US$) of European Union in 1963 to that in 1970?
Offer a very short reply. 0.31. What is the ratio of the Aid flow (current US$) in United Kingdom in 1963 to that in 1970?
Your answer should be very brief. 2.26. What is the ratio of the Aid flow (current US$) of United States in 1963 to that in 1970?
Provide a succinct answer. 3.89. What is the ratio of the Aid flow (current US$) in Iceland in 1963 to that in 1970?
Keep it short and to the point. 1.12. What is the ratio of the Aid flow (current US$) of European Union in 1963 to that in 1971?
Offer a terse response. 0.21. What is the ratio of the Aid flow (current US$) in United Kingdom in 1963 to that in 1971?
Your answer should be very brief. 2.8. What is the ratio of the Aid flow (current US$) of Iceland in 1963 to that in 1971?
Offer a very short reply. 0.65. What is the ratio of the Aid flow (current US$) in European Union in 1964 to that in 1965?
Offer a terse response. 7.77. What is the ratio of the Aid flow (current US$) of United Kingdom in 1964 to that in 1965?
Keep it short and to the point. 1.07. What is the ratio of the Aid flow (current US$) of United States in 1964 to that in 1965?
Your answer should be very brief. 1.34. What is the ratio of the Aid flow (current US$) of Iceland in 1964 to that in 1965?
Your answer should be compact. 1.26. What is the ratio of the Aid flow (current US$) of European Union in 1964 to that in 1966?
Offer a very short reply. 0.42. What is the ratio of the Aid flow (current US$) in United Kingdom in 1964 to that in 1966?
Make the answer very short. 1.01. What is the ratio of the Aid flow (current US$) of United States in 1964 to that in 1966?
Your answer should be very brief. 1.57. What is the ratio of the Aid flow (current US$) of Iceland in 1964 to that in 1966?
Offer a terse response. 0.55. What is the ratio of the Aid flow (current US$) in European Union in 1964 to that in 1967?
Your answer should be very brief. 0.65. What is the ratio of the Aid flow (current US$) in United Kingdom in 1964 to that in 1967?
Make the answer very short. 1.11. What is the ratio of the Aid flow (current US$) of United States in 1964 to that in 1967?
Offer a terse response. 3.01. What is the ratio of the Aid flow (current US$) of Iceland in 1964 to that in 1967?
Give a very brief answer. 0.76. What is the ratio of the Aid flow (current US$) of European Union in 1964 to that in 1969?
Your answer should be compact. 0.63. What is the ratio of the Aid flow (current US$) of United Kingdom in 1964 to that in 1969?
Offer a very short reply. 3.39. What is the ratio of the Aid flow (current US$) of United States in 1964 to that in 1969?
Offer a very short reply. 3.8. What is the ratio of the Aid flow (current US$) of Iceland in 1964 to that in 1969?
Give a very brief answer. 1.13. What is the ratio of the Aid flow (current US$) of European Union in 1964 to that in 1970?
Keep it short and to the point. 0.13. What is the ratio of the Aid flow (current US$) in United Kingdom in 1964 to that in 1970?
Your answer should be very brief. 2.55. What is the ratio of the Aid flow (current US$) of United States in 1964 to that in 1970?
Offer a very short reply. 3.54. What is the ratio of the Aid flow (current US$) of Iceland in 1964 to that in 1970?
Ensure brevity in your answer.  0.8. What is the ratio of the Aid flow (current US$) of European Union in 1964 to that in 1971?
Offer a very short reply. 0.09. What is the ratio of the Aid flow (current US$) of United Kingdom in 1964 to that in 1971?
Your answer should be very brief. 3.16. What is the ratio of the Aid flow (current US$) of United States in 1964 to that in 1971?
Offer a terse response. 2.72. What is the ratio of the Aid flow (current US$) of Iceland in 1964 to that in 1971?
Ensure brevity in your answer.  0.47. What is the ratio of the Aid flow (current US$) of European Union in 1965 to that in 1966?
Ensure brevity in your answer.  0.05. What is the ratio of the Aid flow (current US$) of United Kingdom in 1965 to that in 1966?
Give a very brief answer. 0.94. What is the ratio of the Aid flow (current US$) in United States in 1965 to that in 1966?
Keep it short and to the point. 1.17. What is the ratio of the Aid flow (current US$) in Iceland in 1965 to that in 1966?
Keep it short and to the point. 0.43. What is the ratio of the Aid flow (current US$) of European Union in 1965 to that in 1967?
Offer a very short reply. 0.08. What is the ratio of the Aid flow (current US$) in United Kingdom in 1965 to that in 1967?
Offer a terse response. 1.04. What is the ratio of the Aid flow (current US$) in United States in 1965 to that in 1967?
Provide a succinct answer. 2.25. What is the ratio of the Aid flow (current US$) of Iceland in 1965 to that in 1967?
Ensure brevity in your answer.  0.6. What is the ratio of the Aid flow (current US$) of European Union in 1965 to that in 1969?
Give a very brief answer. 0.08. What is the ratio of the Aid flow (current US$) in United Kingdom in 1965 to that in 1969?
Keep it short and to the point. 3.16. What is the ratio of the Aid flow (current US$) of United States in 1965 to that in 1969?
Your answer should be very brief. 2.84. What is the ratio of the Aid flow (current US$) of Iceland in 1965 to that in 1969?
Keep it short and to the point. 0.9. What is the ratio of the Aid flow (current US$) of European Union in 1965 to that in 1970?
Keep it short and to the point. 0.02. What is the ratio of the Aid flow (current US$) of United Kingdom in 1965 to that in 1970?
Ensure brevity in your answer.  2.38. What is the ratio of the Aid flow (current US$) in United States in 1965 to that in 1970?
Provide a succinct answer. 2.64. What is the ratio of the Aid flow (current US$) in Iceland in 1965 to that in 1970?
Your answer should be compact. 0.64. What is the ratio of the Aid flow (current US$) in European Union in 1965 to that in 1971?
Your response must be concise. 0.01. What is the ratio of the Aid flow (current US$) in United Kingdom in 1965 to that in 1971?
Give a very brief answer. 2.95. What is the ratio of the Aid flow (current US$) in United States in 1965 to that in 1971?
Your response must be concise. 2.04. What is the ratio of the Aid flow (current US$) of Iceland in 1965 to that in 1971?
Offer a terse response. 0.37. What is the ratio of the Aid flow (current US$) of European Union in 1966 to that in 1967?
Offer a very short reply. 1.56. What is the ratio of the Aid flow (current US$) of United Kingdom in 1966 to that in 1967?
Offer a very short reply. 1.11. What is the ratio of the Aid flow (current US$) of United States in 1966 to that in 1967?
Give a very brief answer. 1.92. What is the ratio of the Aid flow (current US$) in Iceland in 1966 to that in 1967?
Provide a short and direct response. 1.4. What is the ratio of the Aid flow (current US$) of European Union in 1966 to that in 1969?
Provide a succinct answer. 1.51. What is the ratio of the Aid flow (current US$) of United Kingdom in 1966 to that in 1969?
Your response must be concise. 3.37. What is the ratio of the Aid flow (current US$) of United States in 1966 to that in 1969?
Provide a short and direct response. 2.42. What is the ratio of the Aid flow (current US$) of Iceland in 1966 to that in 1969?
Offer a very short reply. 2.07. What is the ratio of the Aid flow (current US$) in European Union in 1966 to that in 1970?
Keep it short and to the point. 0.31. What is the ratio of the Aid flow (current US$) in United Kingdom in 1966 to that in 1970?
Make the answer very short. 2.53. What is the ratio of the Aid flow (current US$) in United States in 1966 to that in 1970?
Provide a succinct answer. 2.25. What is the ratio of the Aid flow (current US$) of Iceland in 1966 to that in 1970?
Offer a very short reply. 1.47. What is the ratio of the Aid flow (current US$) of European Union in 1966 to that in 1971?
Offer a very short reply. 0.21. What is the ratio of the Aid flow (current US$) of United Kingdom in 1966 to that in 1971?
Your answer should be very brief. 3.14. What is the ratio of the Aid flow (current US$) in United States in 1966 to that in 1971?
Your response must be concise. 1.73. What is the ratio of the Aid flow (current US$) of Iceland in 1966 to that in 1971?
Provide a short and direct response. 0.85. What is the ratio of the Aid flow (current US$) of European Union in 1967 to that in 1969?
Your response must be concise. 0.97. What is the ratio of the Aid flow (current US$) of United Kingdom in 1967 to that in 1969?
Your answer should be very brief. 3.04. What is the ratio of the Aid flow (current US$) of United States in 1967 to that in 1969?
Offer a very short reply. 1.26. What is the ratio of the Aid flow (current US$) of Iceland in 1967 to that in 1969?
Offer a very short reply. 1.48. What is the ratio of the Aid flow (current US$) in European Union in 1967 to that in 1970?
Provide a short and direct response. 0.2. What is the ratio of the Aid flow (current US$) in United Kingdom in 1967 to that in 1970?
Your answer should be compact. 2.29. What is the ratio of the Aid flow (current US$) in United States in 1967 to that in 1970?
Provide a succinct answer. 1.17. What is the ratio of the Aid flow (current US$) in Iceland in 1967 to that in 1970?
Give a very brief answer. 1.05. What is the ratio of the Aid flow (current US$) in European Union in 1967 to that in 1971?
Your answer should be compact. 0.13. What is the ratio of the Aid flow (current US$) of United Kingdom in 1967 to that in 1971?
Provide a succinct answer. 2.84. What is the ratio of the Aid flow (current US$) of United States in 1967 to that in 1971?
Your response must be concise. 0.9. What is the ratio of the Aid flow (current US$) of Iceland in 1967 to that in 1971?
Make the answer very short. 0.61. What is the ratio of the Aid flow (current US$) of European Union in 1969 to that in 1970?
Your answer should be compact. 0.2. What is the ratio of the Aid flow (current US$) in United Kingdom in 1969 to that in 1970?
Ensure brevity in your answer.  0.75. What is the ratio of the Aid flow (current US$) of United States in 1969 to that in 1970?
Provide a succinct answer. 0.93. What is the ratio of the Aid flow (current US$) of Iceland in 1969 to that in 1970?
Make the answer very short. 0.71. What is the ratio of the Aid flow (current US$) of European Union in 1969 to that in 1971?
Offer a very short reply. 0.14. What is the ratio of the Aid flow (current US$) of United Kingdom in 1969 to that in 1971?
Provide a succinct answer. 0.93. What is the ratio of the Aid flow (current US$) in United States in 1969 to that in 1971?
Your response must be concise. 0.72. What is the ratio of the Aid flow (current US$) of Iceland in 1969 to that in 1971?
Your response must be concise. 0.41. What is the ratio of the Aid flow (current US$) in European Union in 1970 to that in 1971?
Provide a short and direct response. 0.68. What is the ratio of the Aid flow (current US$) in United Kingdom in 1970 to that in 1971?
Keep it short and to the point. 1.24. What is the ratio of the Aid flow (current US$) of United States in 1970 to that in 1971?
Give a very brief answer. 0.77. What is the ratio of the Aid flow (current US$) in Iceland in 1970 to that in 1971?
Provide a short and direct response. 0.58. What is the difference between the highest and the second highest Aid flow (current US$) in European Union?
Make the answer very short. 6.29e+06. What is the difference between the highest and the second highest Aid flow (current US$) in United States?
Offer a terse response. 4.10e+07. What is the difference between the highest and the second highest Aid flow (current US$) in Iceland?
Offer a very short reply. 3.50e+05. What is the difference between the highest and the lowest Aid flow (current US$) in European Union?
Your response must be concise. 1.93e+07. What is the difference between the highest and the lowest Aid flow (current US$) of United Kingdom?
Give a very brief answer. 4.25e+07. What is the difference between the highest and the lowest Aid flow (current US$) in United States?
Your answer should be compact. 3.38e+08. What is the difference between the highest and the lowest Aid flow (current US$) of Iceland?
Keep it short and to the point. 1.49e+06. 